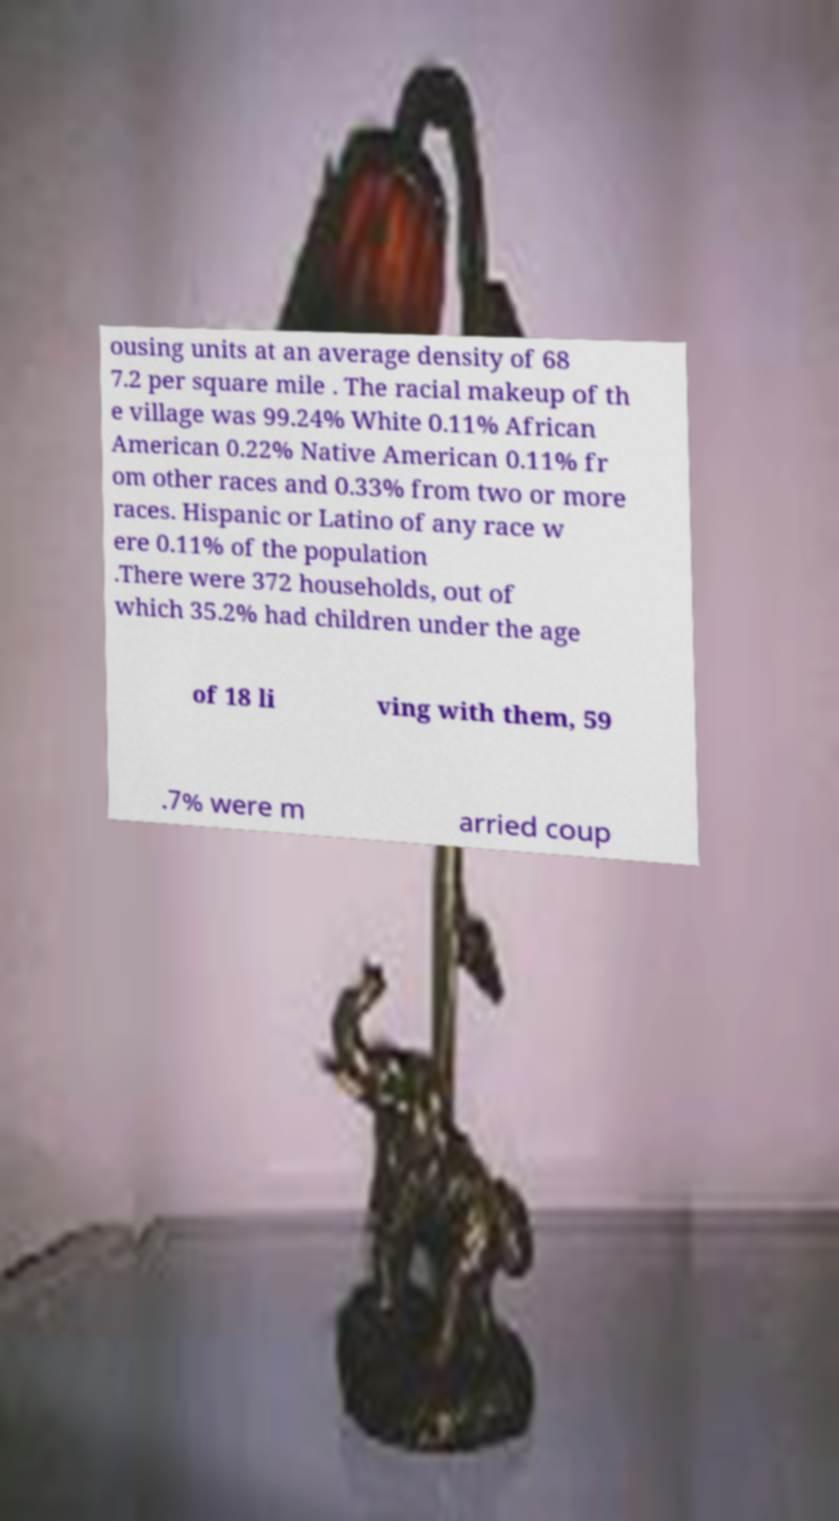Could you assist in decoding the text presented in this image and type it out clearly? ousing units at an average density of 68 7.2 per square mile . The racial makeup of th e village was 99.24% White 0.11% African American 0.22% Native American 0.11% fr om other races and 0.33% from two or more races. Hispanic or Latino of any race w ere 0.11% of the population .There were 372 households, out of which 35.2% had children under the age of 18 li ving with them, 59 .7% were m arried coup 